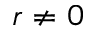<formula> <loc_0><loc_0><loc_500><loc_500>\boldsymbol r \ne 0</formula> 